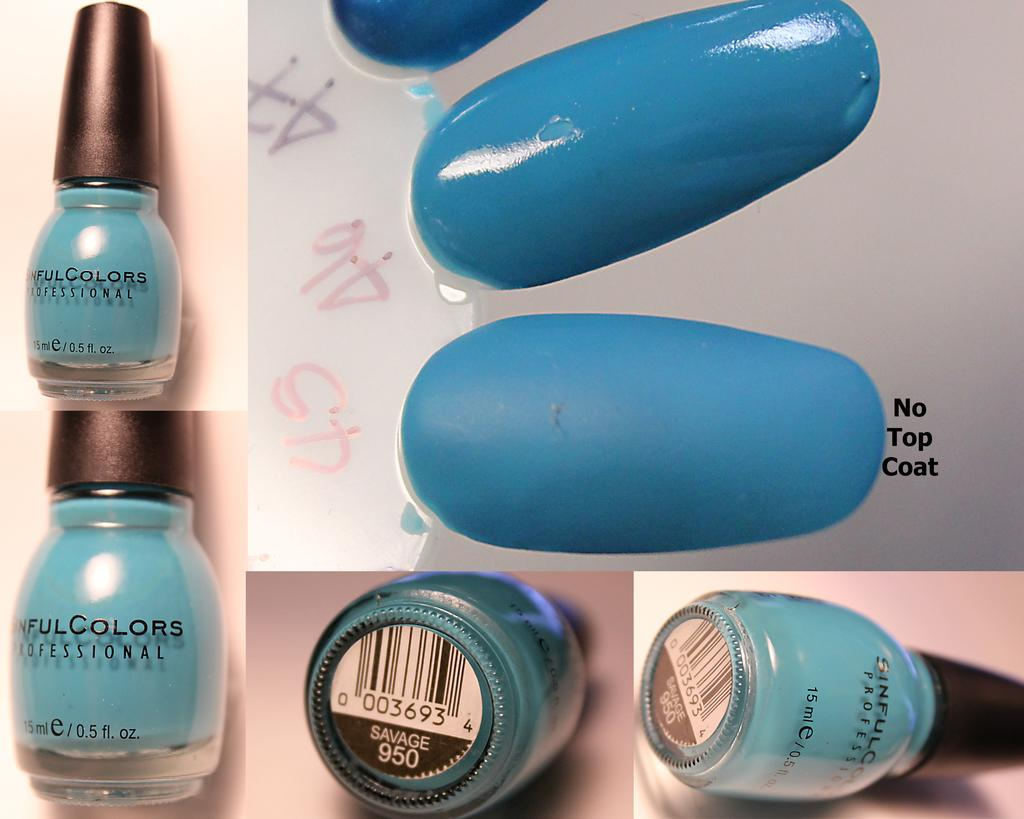<image>
Create a compact narrative representing the image presented. Blue painted acrylic nails with no top coat. 